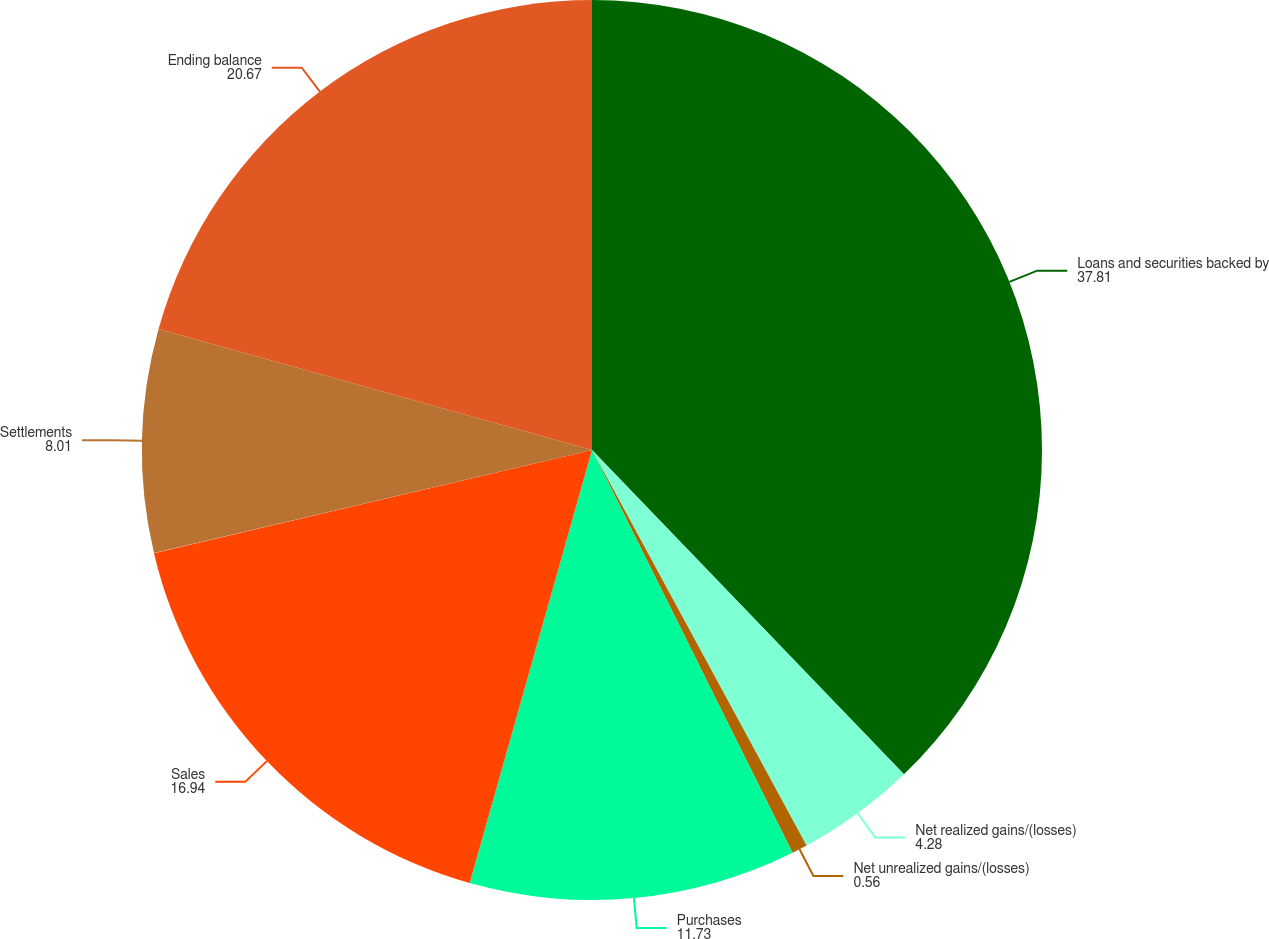Convert chart to OTSL. <chart><loc_0><loc_0><loc_500><loc_500><pie_chart><fcel>Loans and securities backed by<fcel>Net realized gains/(losses)<fcel>Net unrealized gains/(losses)<fcel>Purchases<fcel>Sales<fcel>Settlements<fcel>Ending balance<nl><fcel>37.81%<fcel>4.28%<fcel>0.56%<fcel>11.73%<fcel>16.94%<fcel>8.01%<fcel>20.67%<nl></chart> 